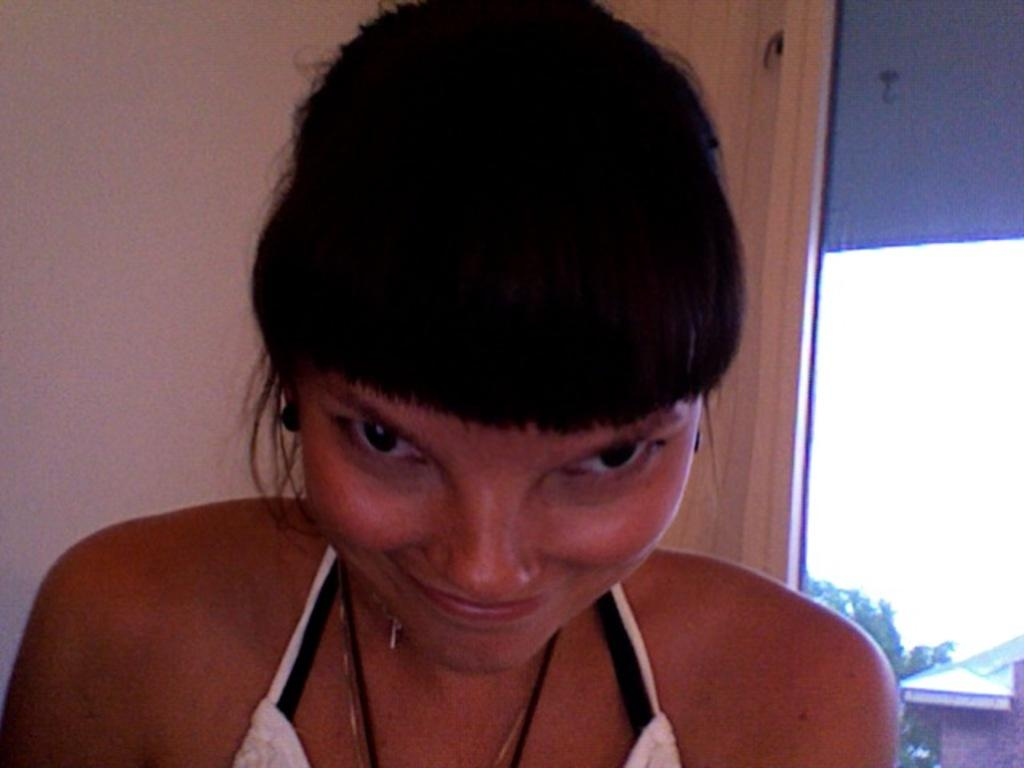Who is present in the image? There is a woman in the picture. What can be seen in the background of the image? There is a wall with a window in the background. What is visible through the window? A tree and a house are visible through the window. Where is the monkey hiding in the image? There is no monkey present in the image. What type of mine is visible in the image? There is no mine present in the image. 